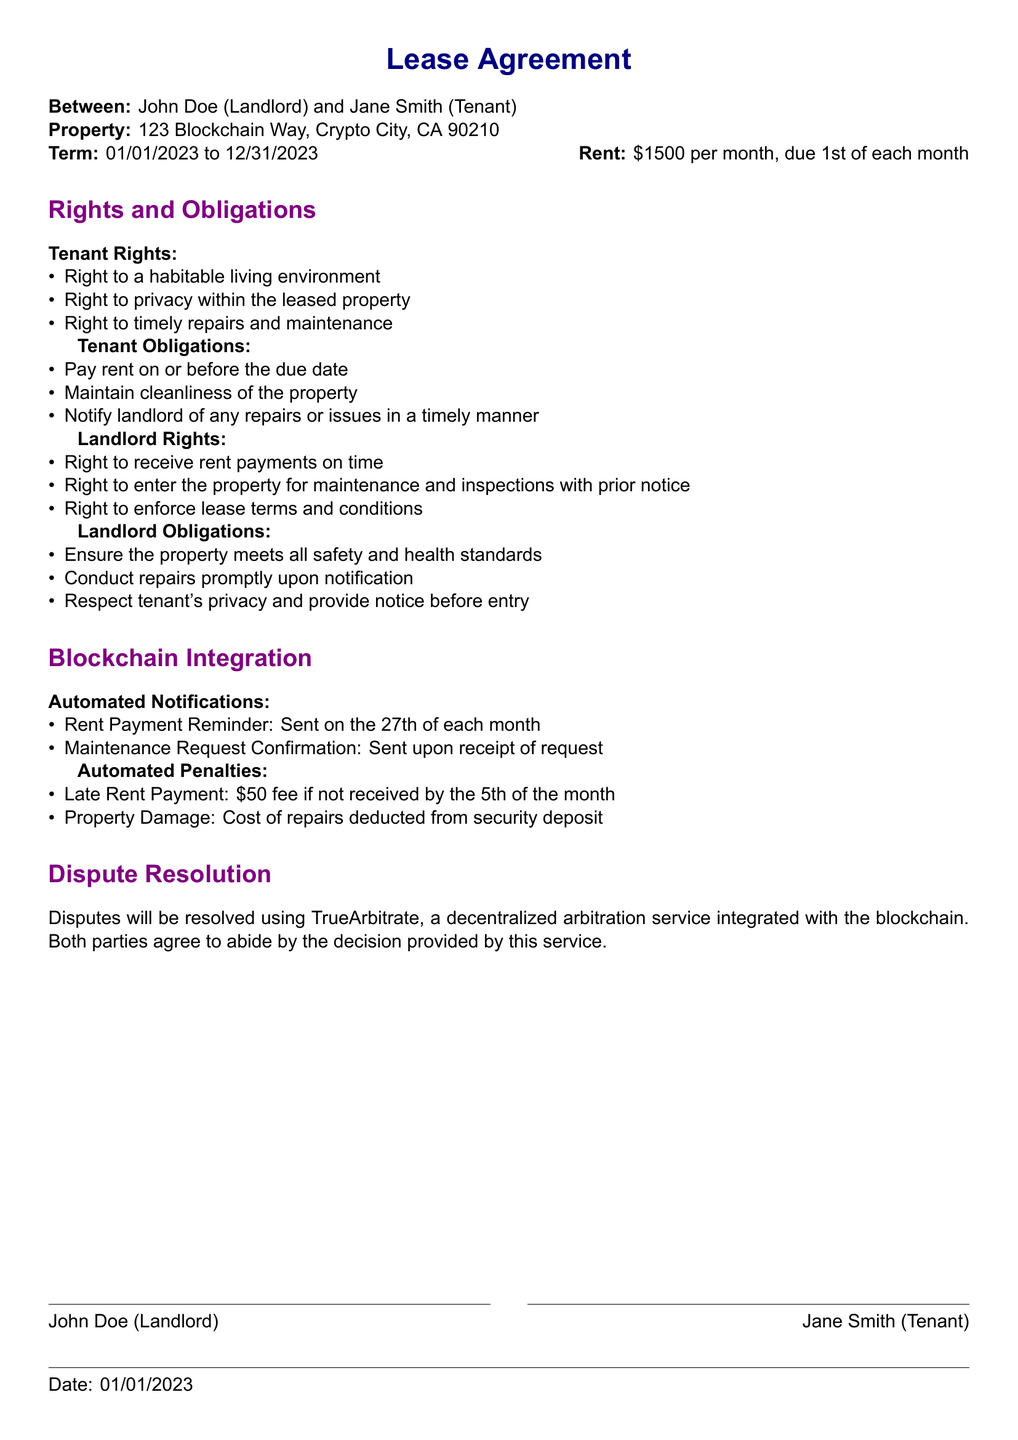What is the name of the tenant? The tenant, as specified in the document, is Jane Smith.
Answer: Jane Smith What is the monthly rent amount? The monthly rent is stated as 1500 dollars.
Answer: 1500 dollars What is the term of the lease? The lease term is specified from January 1, 2023, to December 31, 2023.
Answer: January 1, 2023, to December 31, 2023 What penalty is incurred for late rent payment? A 50-dollar fee is applied for late rent payment if not received by the fifth of the month.
Answer: 50 dollars What is one of the landlord's obligations? The document states that one obligation is to ensure the property meets all safety and health standards.
Answer: Ensure the property meets all safety and health standards How often will rent payment reminders be sent? Rent payment reminders are scheduled to be sent on the 27th of each month.
Answer: 27th of each month Which service is used for dispute resolution? The document mentions using TrueArbitrate for dispute resolution.
Answer: TrueArbitrate What is one tenant obligation mentioned in the document? One obligation listed for the tenant is to maintain cleanliness of the property.
Answer: Maintain cleanliness of the property What right does the tenant have regarding repairs? The tenant has the right to timely repairs and maintenance.
Answer: Timely repairs and maintenance 